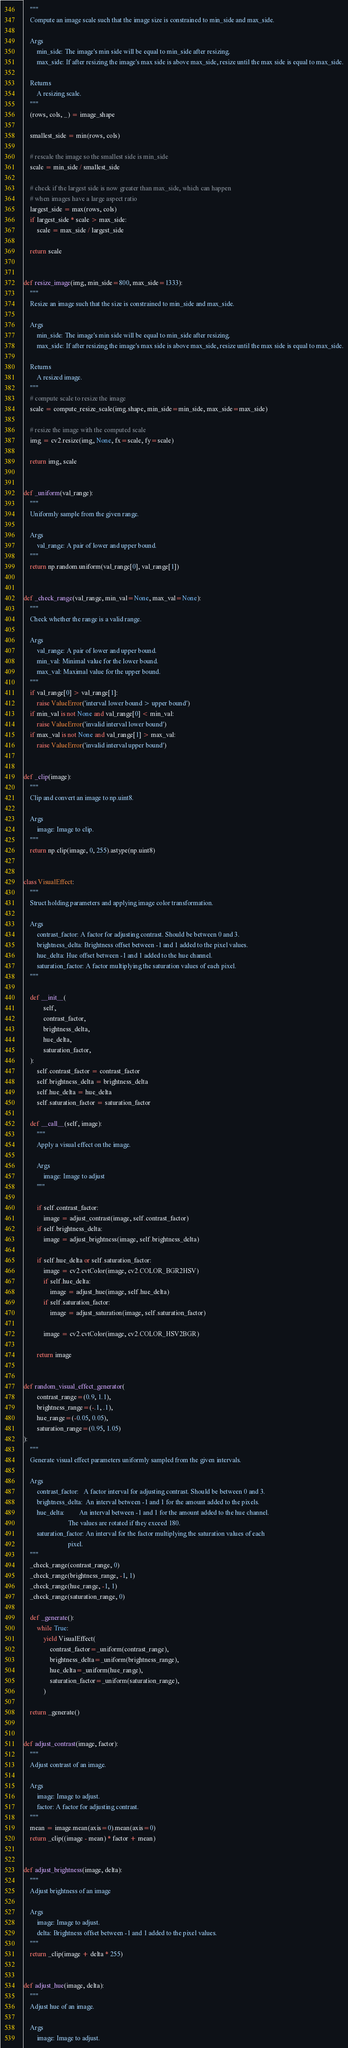<code> <loc_0><loc_0><loc_500><loc_500><_Python_>    """
    Compute an image scale such that the image size is constrained to min_side and max_side.

    Args
        min_side: The image's min side will be equal to min_side after resizing.
        max_side: If after resizing the image's max side is above max_side, resize until the max side is equal to max_side.

    Returns
        A resizing scale.
    """
    (rows, cols, _) = image_shape

    smallest_side = min(rows, cols)

    # rescale the image so the smallest side is min_side
    scale = min_side / smallest_side

    # check if the largest side is now greater than max_side, which can happen
    # when images have a large aspect ratio
    largest_side = max(rows, cols)
    if largest_side * scale > max_side:
        scale = max_side / largest_side

    return scale


def resize_image(img, min_side=800, max_side=1333):
    """
    Resize an image such that the size is constrained to min_side and max_side.

    Args
        min_side: The image's min side will be equal to min_side after resizing.
        max_side: If after resizing the image's max side is above max_side, resize until the max side is equal to max_side.

    Returns
        A resized image.
    """
    # compute scale to resize the image
    scale = compute_resize_scale(img.shape, min_side=min_side, max_side=max_side)

    # resize the image with the computed scale
    img = cv2.resize(img, None, fx=scale, fy=scale)

    return img, scale


def _uniform(val_range):
    """
    Uniformly sample from the given range.

    Args
        val_range: A pair of lower and upper bound.
    """
    return np.random.uniform(val_range[0], val_range[1])


def _check_range(val_range, min_val=None, max_val=None):
    """
    Check whether the range is a valid range.

    Args
        val_range: A pair of lower and upper bound.
        min_val: Minimal value for the lower bound.
        max_val: Maximal value for the upper bound.
    """
    if val_range[0] > val_range[1]:
        raise ValueError('interval lower bound > upper bound')
    if min_val is not None and val_range[0] < min_val:
        raise ValueError('invalid interval lower bound')
    if max_val is not None and val_range[1] > max_val:
        raise ValueError('invalid interval upper bound')


def _clip(image):
    """
    Clip and convert an image to np.uint8.

    Args
        image: Image to clip.
    """
    return np.clip(image, 0, 255).astype(np.uint8)


class VisualEffect:
    """
    Struct holding parameters and applying image color transformation.

    Args
        contrast_factor: A factor for adjusting contrast. Should be between 0 and 3.
        brightness_delta: Brightness offset between -1 and 1 added to the pixel values.
        hue_delta: Hue offset between -1 and 1 added to the hue channel.
        saturation_factor: A factor multiplying the saturation values of each pixel.
    """

    def __init__(
            self,
            contrast_factor,
            brightness_delta,
            hue_delta,
            saturation_factor,
    ):
        self.contrast_factor = contrast_factor
        self.brightness_delta = brightness_delta
        self.hue_delta = hue_delta
        self.saturation_factor = saturation_factor

    def __call__(self, image):
        """
        Apply a visual effect on the image.

        Args
            image: Image to adjust
        """

        if self.contrast_factor:
            image = adjust_contrast(image, self.contrast_factor)
        if self.brightness_delta:
            image = adjust_brightness(image, self.brightness_delta)

        if self.hue_delta or self.saturation_factor:
            image = cv2.cvtColor(image, cv2.COLOR_BGR2HSV)
            if self.hue_delta:
                image = adjust_hue(image, self.hue_delta)
            if self.saturation_factor:
                image = adjust_saturation(image, self.saturation_factor)

            image = cv2.cvtColor(image, cv2.COLOR_HSV2BGR)

        return image


def random_visual_effect_generator(
        contrast_range=(0.9, 1.1),
        brightness_range=(-.1, .1),
        hue_range=(-0.05, 0.05),
        saturation_range=(0.95, 1.05)
):
    """
    Generate visual effect parameters uniformly sampled from the given intervals.

    Args
        contrast_factor:   A factor interval for adjusting contrast. Should be between 0 and 3.
        brightness_delta:  An interval between -1 and 1 for the amount added to the pixels.
        hue_delta:         An interval between -1 and 1 for the amount added to the hue channel.
                           The values are rotated if they exceed 180.
        saturation_factor: An interval for the factor multiplying the saturation values of each
                           pixel.
    """
    _check_range(contrast_range, 0)
    _check_range(brightness_range, -1, 1)
    _check_range(hue_range, -1, 1)
    _check_range(saturation_range, 0)

    def _generate():
        while True:
            yield VisualEffect(
                contrast_factor=_uniform(contrast_range),
                brightness_delta=_uniform(brightness_range),
                hue_delta=_uniform(hue_range),
                saturation_factor=_uniform(saturation_range),
            )

    return _generate()


def adjust_contrast(image, factor):
    """
    Adjust contrast of an image.

    Args
        image: Image to adjust.
        factor: A factor for adjusting contrast.
    """
    mean = image.mean(axis=0).mean(axis=0)
    return _clip((image - mean) * factor + mean)


def adjust_brightness(image, delta):
    """
    Adjust brightness of an image

    Args
        image: Image to adjust.
        delta: Brightness offset between -1 and 1 added to the pixel values.
    """
    return _clip(image + delta * 255)


def adjust_hue(image, delta):
    """
    Adjust hue of an image.

    Args
        image: Image to adjust.</code> 